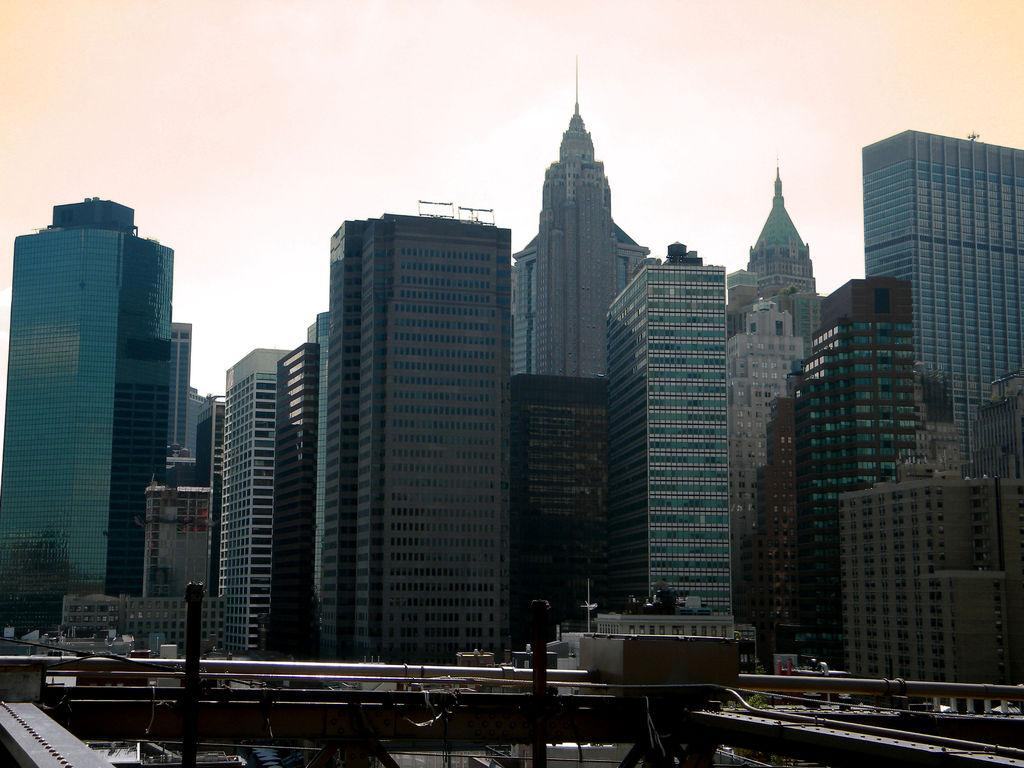What structures are located in the middle of the image? There are buildings in the middle of the image. What can be seen in the sky in the image? There are clouds in the sky. What part of the natural environment is visible in the image? The sky is visible in the image. What type of barrier is present at the bottom of the image? There is fencing at the bottom of the image. How many fingers can be seen pointing at the buildings in the image? There are no fingers visible in the image, so it is not possible to determine how many fingers might be pointing at the buildings. 